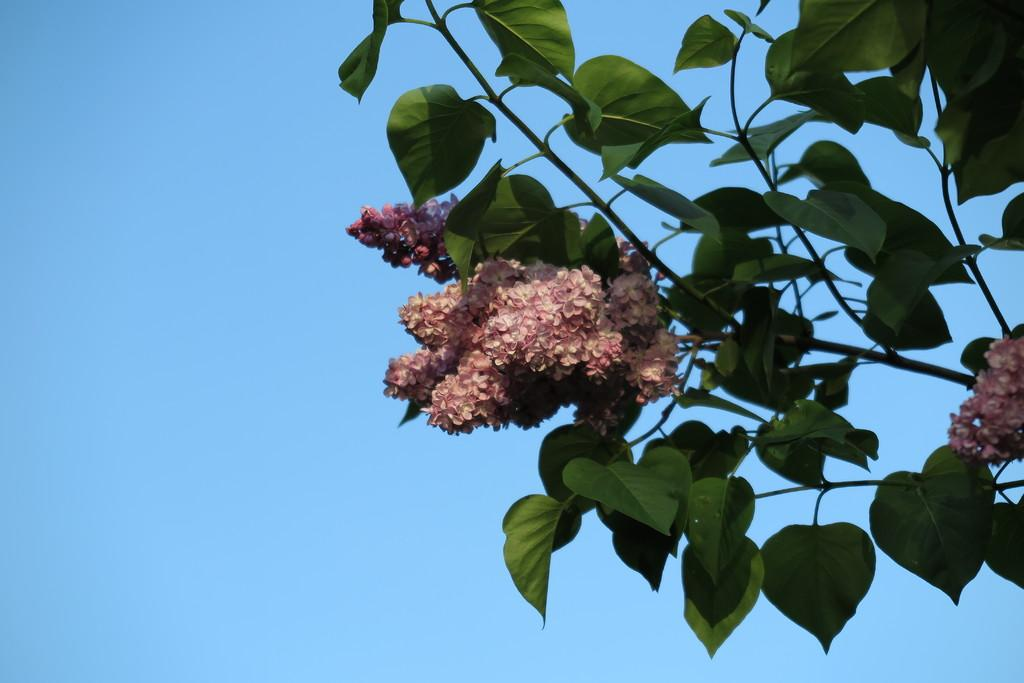What type of plant can be seen in the image? There is a flower plant in the image. What can be seen in the background of the image? The sky is visible in the background of the image. What type of jeans is the flower plant wearing in the image? There are no jeans present in the image, as the subject is a flower plant, which does not wear clothing. 